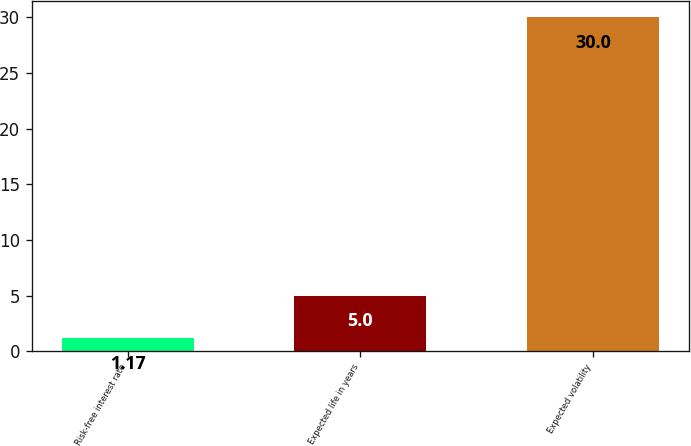Convert chart. <chart><loc_0><loc_0><loc_500><loc_500><bar_chart><fcel>Risk-free interest rate<fcel>Expected life in years<fcel>Expected volatility<nl><fcel>1.17<fcel>5<fcel>30<nl></chart> 